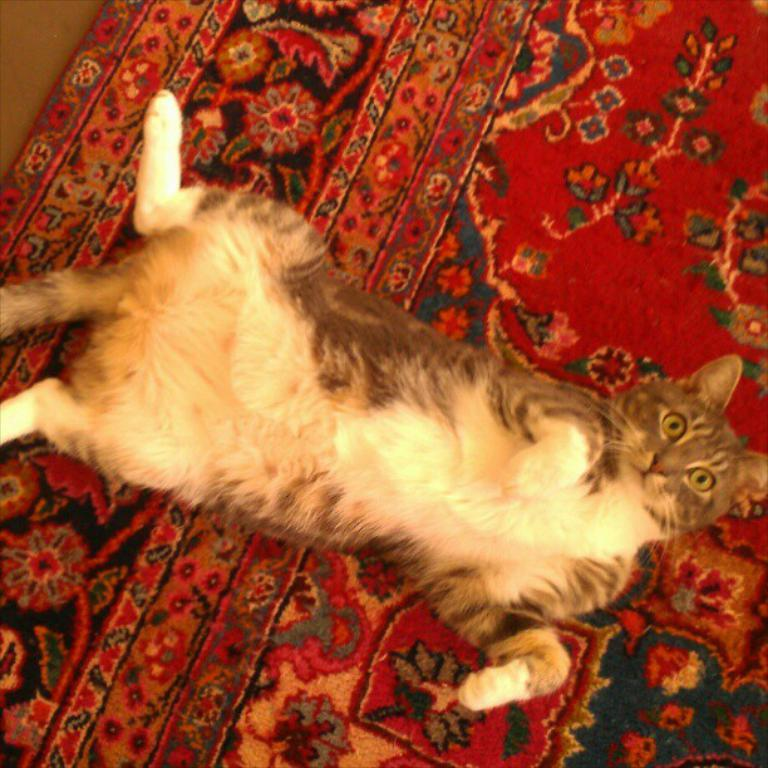What animal can be seen in the image? There is a cat in the image. What surface is the cat laying on? The cat is laying on a carpet. What position is the cat in? The cat is laying on its back. How would you describe the cat's facial expression? The cat is giving a weird expression. What type of leaf can be seen falling during the party in the image? There is no leaf or party present in the image; it features a cat laying on a carpet. How many people are attending the quiet event in the image? There is no event or people present in the image; it features a cat laying on a carpet. 